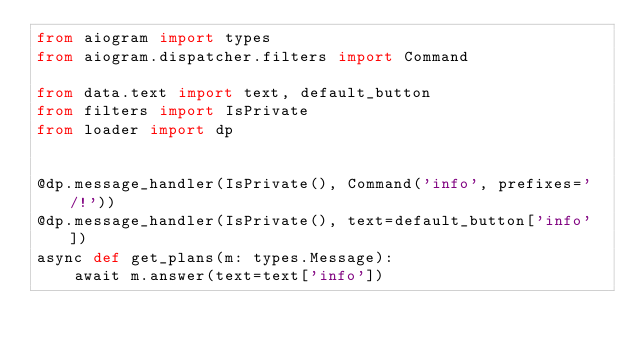<code> <loc_0><loc_0><loc_500><loc_500><_Python_>from aiogram import types
from aiogram.dispatcher.filters import Command

from data.text import text, default_button
from filters import IsPrivate
from loader import dp


@dp.message_handler(IsPrivate(), Command('info', prefixes='/!'))
@dp.message_handler(IsPrivate(), text=default_button['info'])
async def get_plans(m: types.Message):
    await m.answer(text=text['info'])

</code> 